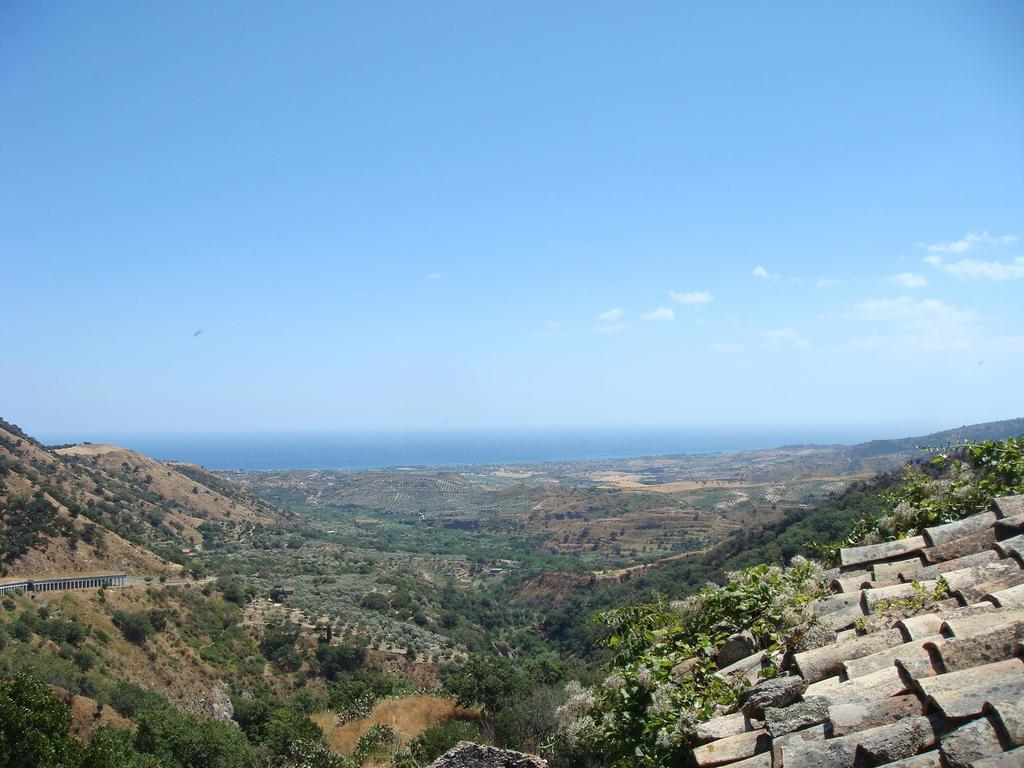What type of natural features can be seen in the image? There are trees and mountains in the image. What is the condition of the sky in the image? The sky is cloudy in the image. What type of surface can be seen on the right side of the image? There are tiles on the right side of the image. Can you see a guitar being played in the image? There is no guitar or any musical instrument visible in the image. What letters are being used to form words in the image? There are no letters or words present in the image. 